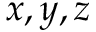<formula> <loc_0><loc_0><loc_500><loc_500>x , y , z</formula> 